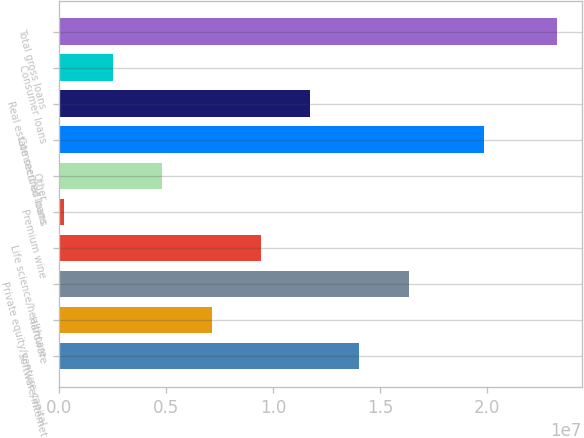<chart> <loc_0><loc_0><loc_500><loc_500><bar_chart><fcel>Software/internet<fcel>Hardware<fcel>Private equity/venture capital<fcel>Life science/healthcare<fcel>Premium wine<fcel>Other<fcel>Commercial loans<fcel>Real estate secured loans<fcel>Consumer loans<fcel>Total gross loans<nl><fcel>1.40342e+07<fcel>7.11923e+06<fcel>1.63392e+07<fcel>9.42422e+06<fcel>204257<fcel>4.81424e+06<fcel>1.98464e+07<fcel>1.17292e+07<fcel>2.50925e+06<fcel>2.32542e+07<nl></chart> 